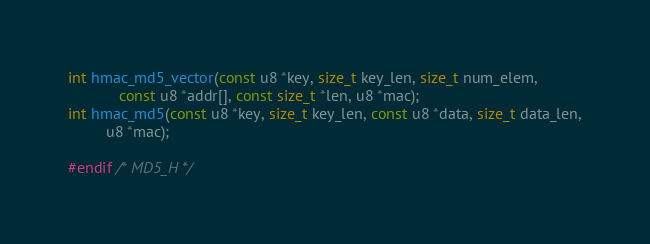<code> <loc_0><loc_0><loc_500><loc_500><_C_>int hmac_md5_vector(const u8 *key, size_t key_len, size_t num_elem,
		    const u8 *addr[], const size_t *len, u8 *mac);
int hmac_md5(const u8 *key, size_t key_len, const u8 *data, size_t data_len,
	     u8 *mac);

#endif /* MD5_H */
</code> 